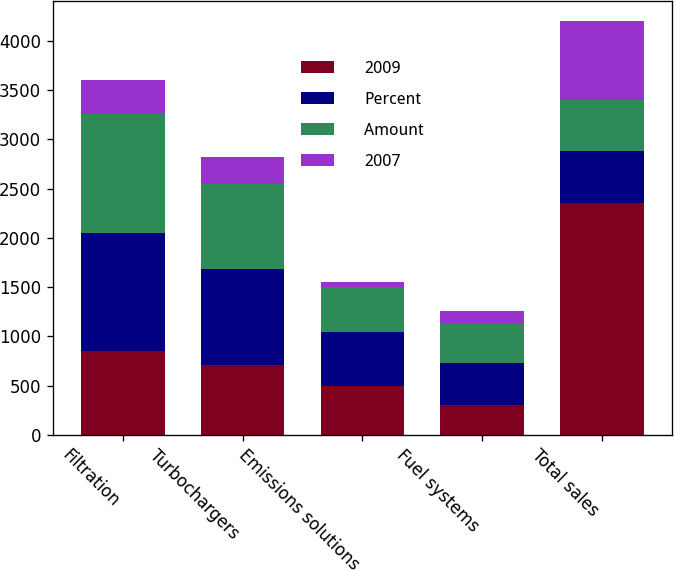Convert chart. <chart><loc_0><loc_0><loc_500><loc_500><stacked_bar_chart><ecel><fcel>Filtration<fcel>Turbochargers<fcel>Emissions solutions<fcel>Fuel systems<fcel>Total sales<nl><fcel>2009<fcel>851<fcel>704<fcel>495<fcel>305<fcel>2355<nl><fcel>Percent<fcel>1194<fcel>979<fcel>553<fcel>426<fcel>524<nl><fcel>Amount<fcel>1215<fcel>860<fcel>448<fcel>409<fcel>524<nl><fcel>2007<fcel>343<fcel>275<fcel>58<fcel>121<fcel>797<nl></chart> 